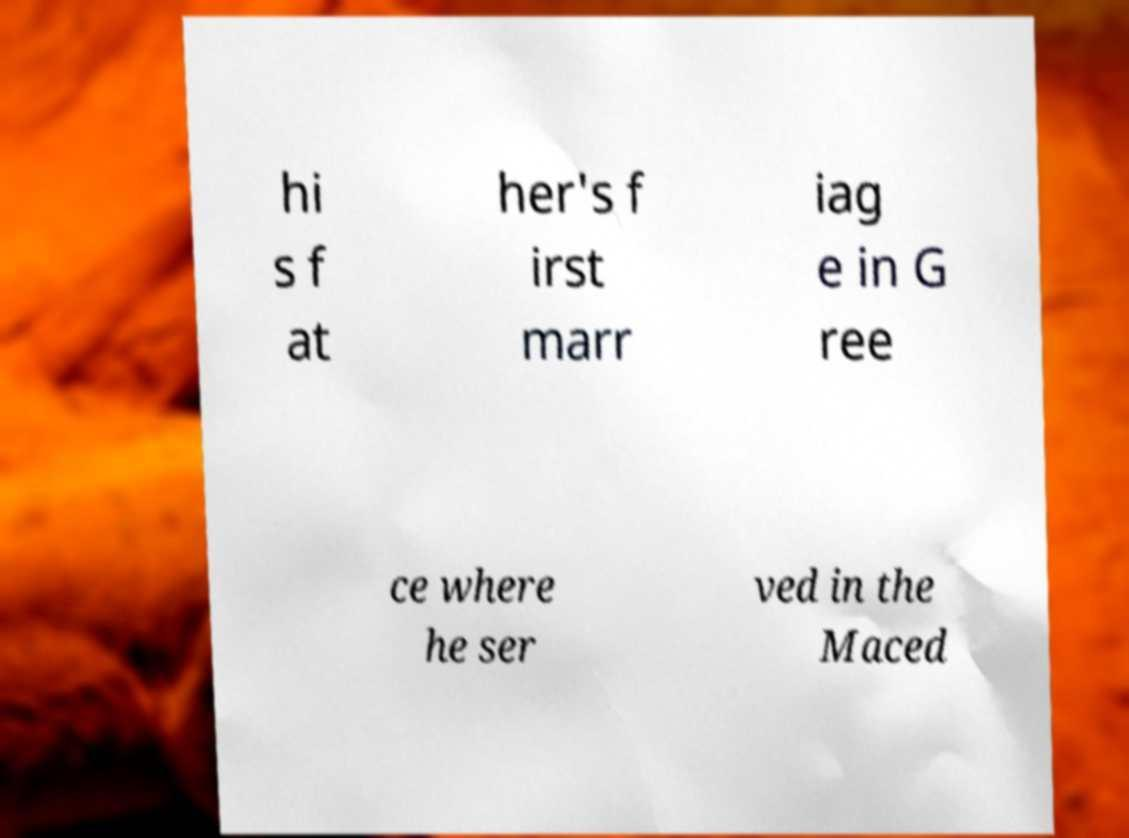Please identify and transcribe the text found in this image. hi s f at her's f irst marr iag e in G ree ce where he ser ved in the Maced 